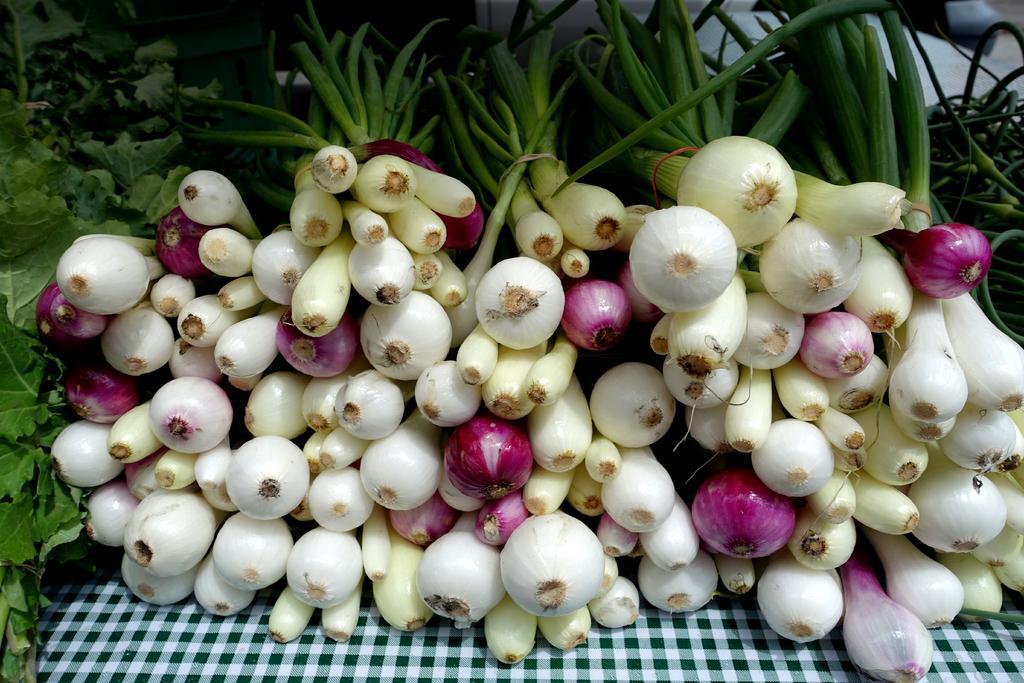Describe this image in one or two sentences. In this picture we can see onions and leaves and these are placed on a cloth. 